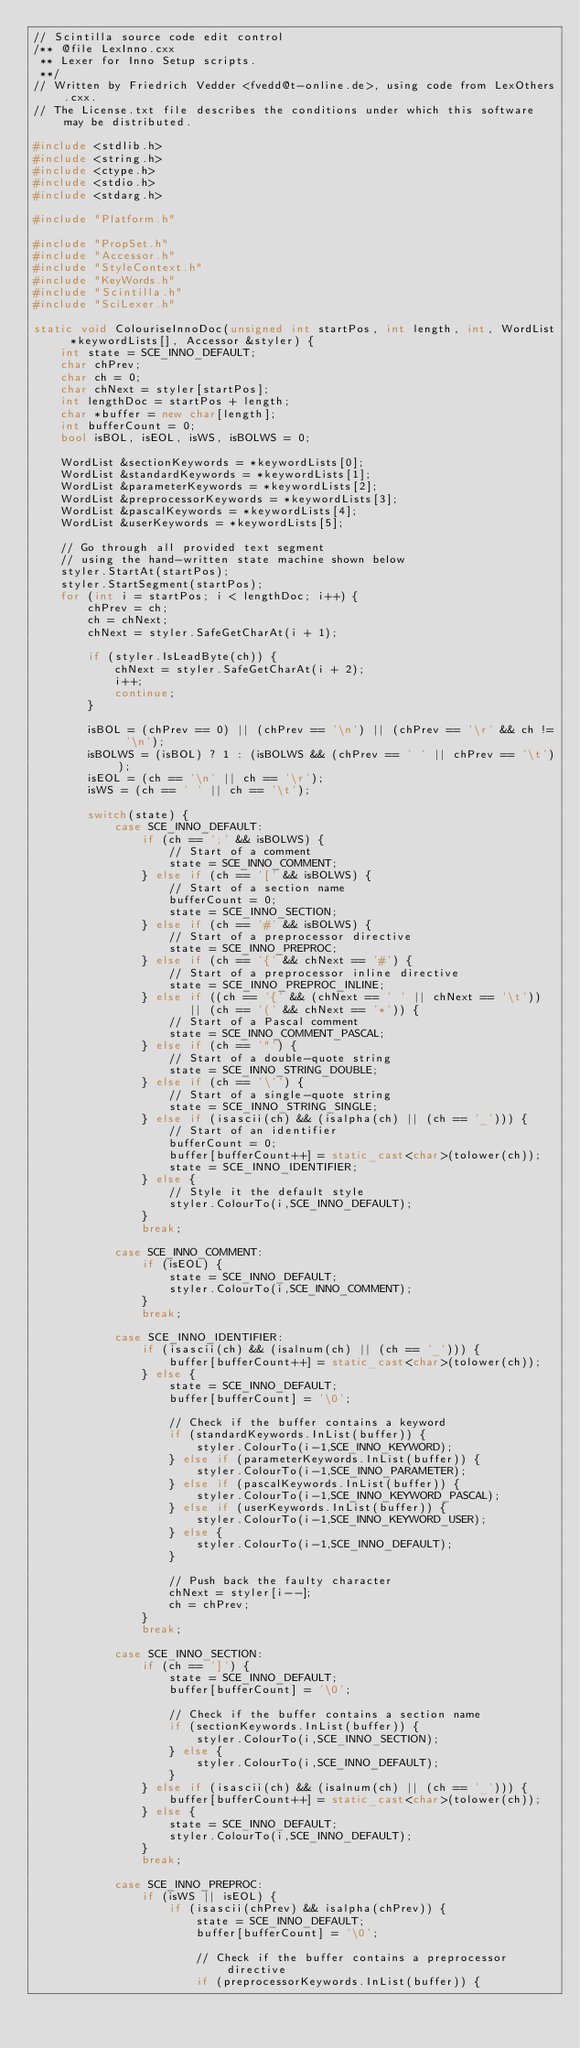Convert code to text. <code><loc_0><loc_0><loc_500><loc_500><_C++_>// Scintilla source code edit control
/** @file LexInno.cxx
 ** Lexer for Inno Setup scripts.
 **/
// Written by Friedrich Vedder <fvedd@t-online.de>, using code from LexOthers.cxx.
// The License.txt file describes the conditions under which this software may be distributed.

#include <stdlib.h>
#include <string.h>
#include <ctype.h>
#include <stdio.h>
#include <stdarg.h>

#include "Platform.h"

#include "PropSet.h"
#include "Accessor.h"
#include "StyleContext.h"
#include "KeyWords.h"
#include "Scintilla.h"
#include "SciLexer.h"

static void ColouriseInnoDoc(unsigned int startPos, int length, int, WordList *keywordLists[], Accessor &styler) {
	int state = SCE_INNO_DEFAULT;
	char chPrev;
	char ch = 0;
	char chNext = styler[startPos];
	int lengthDoc = startPos + length;
	char *buffer = new char[length];
	int bufferCount = 0;
	bool isBOL, isEOL, isWS, isBOLWS = 0;

	WordList &sectionKeywords = *keywordLists[0];
	WordList &standardKeywords = *keywordLists[1];
	WordList &parameterKeywords = *keywordLists[2];
	WordList &preprocessorKeywords = *keywordLists[3];
	WordList &pascalKeywords = *keywordLists[4];
	WordList &userKeywords = *keywordLists[5];

	// Go through all provided text segment
	// using the hand-written state machine shown below
	styler.StartAt(startPos);
	styler.StartSegment(startPos);
	for (int i = startPos; i < lengthDoc; i++) {
		chPrev = ch;
		ch = chNext;
		chNext = styler.SafeGetCharAt(i + 1);

		if (styler.IsLeadByte(ch)) {
			chNext = styler.SafeGetCharAt(i + 2);
			i++;
			continue;
		}

		isBOL = (chPrev == 0) || (chPrev == '\n') || (chPrev == '\r' && ch != '\n');
		isBOLWS = (isBOL) ? 1 : (isBOLWS && (chPrev == ' ' || chPrev == '\t'));
		isEOL = (ch == '\n' || ch == '\r');
		isWS = (ch == ' ' || ch == '\t');

		switch(state) {
			case SCE_INNO_DEFAULT:
				if (ch == ';' && isBOLWS) {
					// Start of a comment
					state = SCE_INNO_COMMENT;
				} else if (ch == '[' && isBOLWS) {
					// Start of a section name
					bufferCount = 0;
					state = SCE_INNO_SECTION;
				} else if (ch == '#' && isBOLWS) {
					// Start of a preprocessor directive
					state = SCE_INNO_PREPROC;
				} else if (ch == '{' && chNext == '#') {
					// Start of a preprocessor inline directive
					state = SCE_INNO_PREPROC_INLINE;
				} else if ((ch == '{' && (chNext == ' ' || chNext == '\t'))
					   || (ch == '(' && chNext == '*')) {
					// Start of a Pascal comment
					state = SCE_INNO_COMMENT_PASCAL;
				} else if (ch == '"') {
					// Start of a double-quote string
					state = SCE_INNO_STRING_DOUBLE;
				} else if (ch == '\'') {
					// Start of a single-quote string
					state = SCE_INNO_STRING_SINGLE;
				} else if (isascii(ch) && (isalpha(ch) || (ch == '_'))) {
					// Start of an identifier
					bufferCount = 0;
					buffer[bufferCount++] = static_cast<char>(tolower(ch));
					state = SCE_INNO_IDENTIFIER;
				} else {
					// Style it the default style
					styler.ColourTo(i,SCE_INNO_DEFAULT);
				}
				break;

			case SCE_INNO_COMMENT:
				if (isEOL) {
					state = SCE_INNO_DEFAULT;
					styler.ColourTo(i,SCE_INNO_COMMENT);
				}
				break;

			case SCE_INNO_IDENTIFIER:
				if (isascii(ch) && (isalnum(ch) || (ch == '_'))) {
					buffer[bufferCount++] = static_cast<char>(tolower(ch));
				} else {
					state = SCE_INNO_DEFAULT;
					buffer[bufferCount] = '\0';

					// Check if the buffer contains a keyword
					if (standardKeywords.InList(buffer)) {
						styler.ColourTo(i-1,SCE_INNO_KEYWORD);
					} else if (parameterKeywords.InList(buffer)) {
						styler.ColourTo(i-1,SCE_INNO_PARAMETER);
					} else if (pascalKeywords.InList(buffer)) {
						styler.ColourTo(i-1,SCE_INNO_KEYWORD_PASCAL);
					} else if (userKeywords.InList(buffer)) {
						styler.ColourTo(i-1,SCE_INNO_KEYWORD_USER);
					} else {
						styler.ColourTo(i-1,SCE_INNO_DEFAULT);
					}

					// Push back the faulty character
					chNext = styler[i--];
					ch = chPrev;
				}
				break;

			case SCE_INNO_SECTION:
				if (ch == ']') {
					state = SCE_INNO_DEFAULT;
					buffer[bufferCount] = '\0';

					// Check if the buffer contains a section name
					if (sectionKeywords.InList(buffer)) {
						styler.ColourTo(i,SCE_INNO_SECTION);
					} else {
						styler.ColourTo(i,SCE_INNO_DEFAULT);
					}
				} else if (isascii(ch) && (isalnum(ch) || (ch == '_'))) {
					buffer[bufferCount++] = static_cast<char>(tolower(ch));
				} else {
					state = SCE_INNO_DEFAULT;
					styler.ColourTo(i,SCE_INNO_DEFAULT);
				}
				break;

			case SCE_INNO_PREPROC:
				if (isWS || isEOL) {
					if (isascii(chPrev) && isalpha(chPrev)) {
						state = SCE_INNO_DEFAULT;
						buffer[bufferCount] = '\0';

						// Check if the buffer contains a preprocessor directive
						if (preprocessorKeywords.InList(buffer)) {</code> 